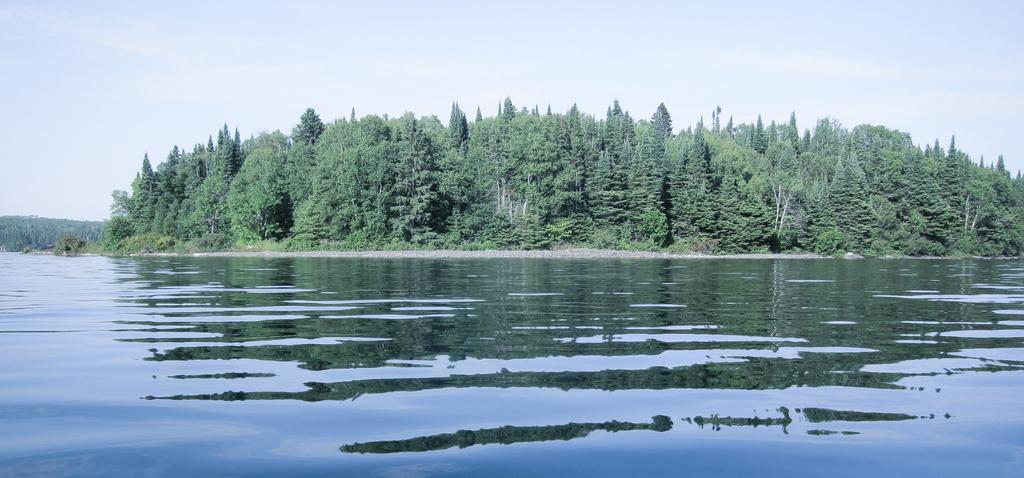What type of natural feature is present in the image? There is a river in the image. What other natural elements can be seen in the image? There are trees in the image. What is visible in the background of the image? The sky is visible in the image. What type of cloth is being used to fan the flame in the image? There is no flame or cloth present in the image; it features a river, trees, and the sky. 